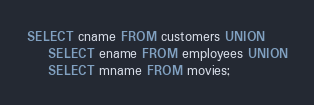Convert code to text. <code><loc_0><loc_0><loc_500><loc_500><_SQL_>SELECT cname FROM customers UNION
	SELECT ename FROM employees UNION
	SELECT mname FROM movies;
</code> 